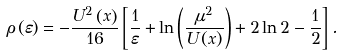<formula> <loc_0><loc_0><loc_500><loc_500>\rho \left ( \varepsilon \right ) = - \frac { U ^ { 2 } \left ( x \right ) } { 1 6 } \left [ \frac { 1 } { \varepsilon } + \ln \left ( \frac { \mu ^ { 2 } } { U \left ( x \right ) } \right ) + 2 \ln 2 - \frac { 1 } { 2 } \right ] .</formula> 